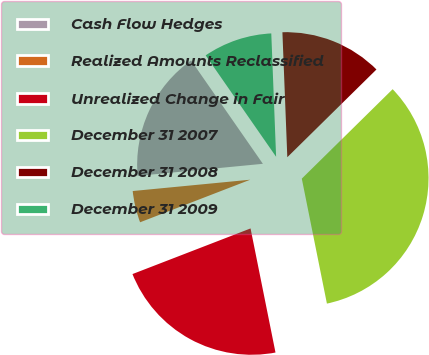Convert chart to OTSL. <chart><loc_0><loc_0><loc_500><loc_500><pie_chart><fcel>Cash Flow Hedges<fcel>Realized Amounts Reclassified<fcel>Unrealized Change in Fair<fcel>December 31 2007<fcel>December 31 2008<fcel>December 31 2009<nl><fcel>16.87%<fcel>4.34%<fcel>22.29%<fcel>34.22%<fcel>13.25%<fcel>9.04%<nl></chart> 